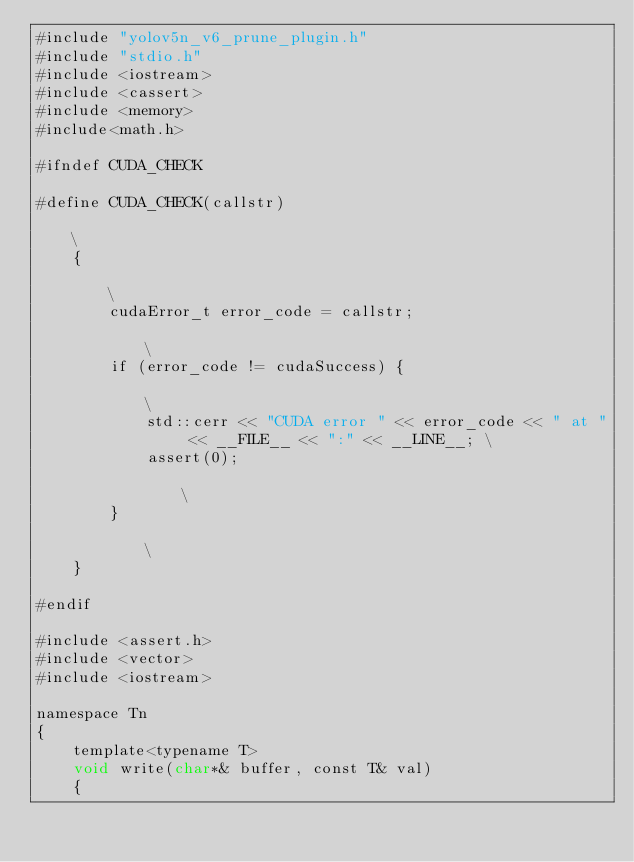Convert code to text. <code><loc_0><loc_0><loc_500><loc_500><_Cuda_>#include "yolov5n_v6_prune_plugin.h"
#include "stdio.h"
#include <iostream>
#include <cassert>
#include <memory>
#include<math.h>

#ifndef CUDA_CHECK

#define CUDA_CHECK(callstr)                                                                    \
    {                                                                                          \
        cudaError_t error_code = callstr;                                                      \
        if (error_code != cudaSuccess) {                                                       \
            std::cerr << "CUDA error " << error_code << " at " << __FILE__ << ":" << __LINE__; \
            assert(0);                                                                         \
        }                                                                                      \
    }

#endif

#include <assert.h>
#include <vector>
#include <iostream>

namespace Tn
{
    template<typename T>
    void write(char*& buffer, const T& val)
    {</code> 